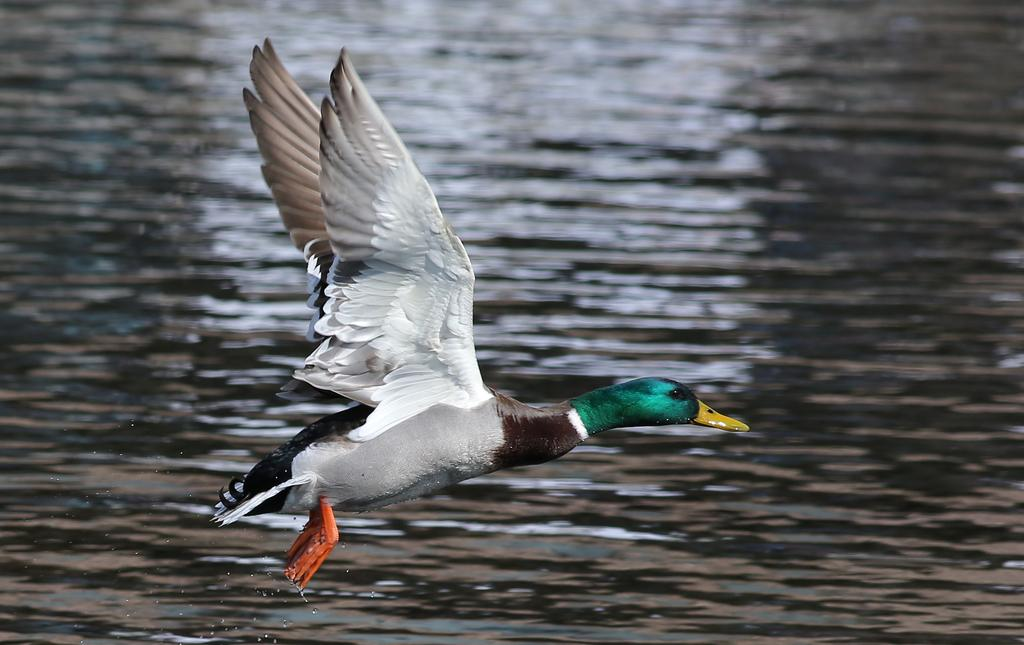What type of animal is present in the image? There is a bird in the image. What is the bird doing in the image? The bird is flying. What is the color scheme of the image? The image is in black and white, but it also has green color. What natural element can be seen in the image? There is water visible in the image. How many books are stacked on the wrist of the bird in the image? There are no books or wrists present in the image; it features a bird flying with water visible in the background. 